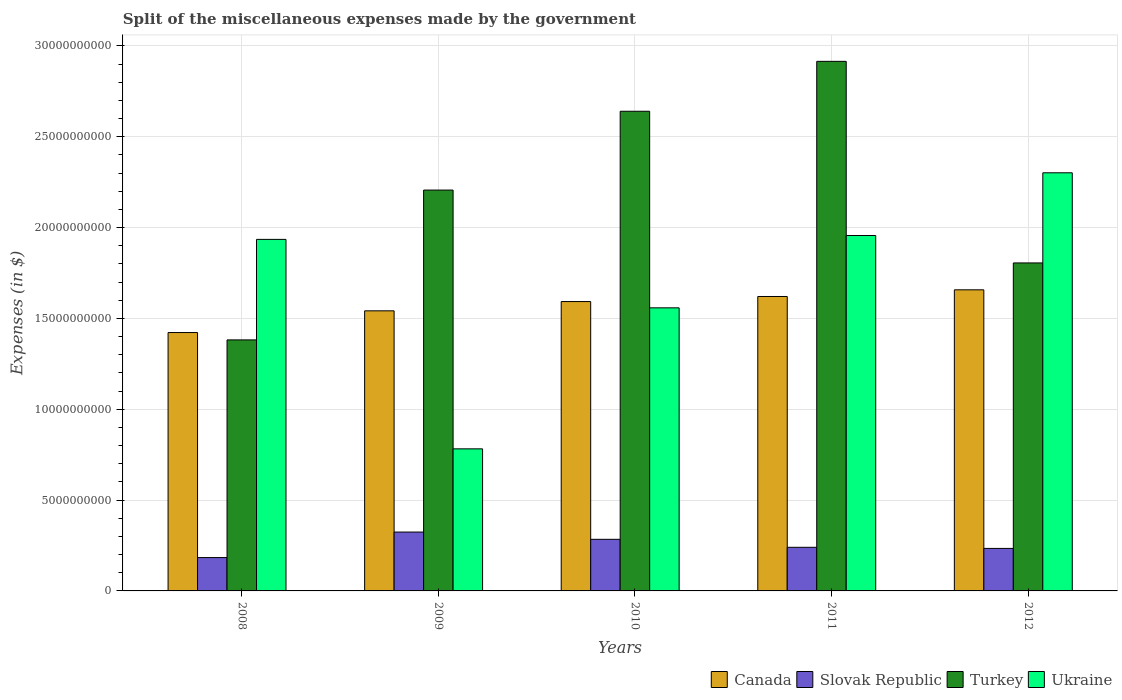How many different coloured bars are there?
Offer a terse response. 4. How many groups of bars are there?
Provide a succinct answer. 5. Are the number of bars per tick equal to the number of legend labels?
Offer a terse response. Yes. Are the number of bars on each tick of the X-axis equal?
Your response must be concise. Yes. How many bars are there on the 1st tick from the right?
Ensure brevity in your answer.  4. What is the label of the 4th group of bars from the left?
Provide a succinct answer. 2011. What is the miscellaneous expenses made by the government in Turkey in 2010?
Your answer should be compact. 2.64e+1. Across all years, what is the maximum miscellaneous expenses made by the government in Slovak Republic?
Your answer should be compact. 3.24e+09. Across all years, what is the minimum miscellaneous expenses made by the government in Slovak Republic?
Ensure brevity in your answer.  1.84e+09. In which year was the miscellaneous expenses made by the government in Canada minimum?
Your response must be concise. 2008. What is the total miscellaneous expenses made by the government in Turkey in the graph?
Offer a terse response. 1.09e+11. What is the difference between the miscellaneous expenses made by the government in Slovak Republic in 2010 and that in 2011?
Your response must be concise. 4.40e+08. What is the difference between the miscellaneous expenses made by the government in Turkey in 2010 and the miscellaneous expenses made by the government in Slovak Republic in 2012?
Offer a very short reply. 2.41e+1. What is the average miscellaneous expenses made by the government in Ukraine per year?
Offer a very short reply. 1.71e+1. In the year 2010, what is the difference between the miscellaneous expenses made by the government in Canada and miscellaneous expenses made by the government in Turkey?
Offer a very short reply. -1.05e+1. What is the ratio of the miscellaneous expenses made by the government in Turkey in 2008 to that in 2009?
Offer a very short reply. 0.63. Is the miscellaneous expenses made by the government in Turkey in 2008 less than that in 2010?
Keep it short and to the point. Yes. What is the difference between the highest and the second highest miscellaneous expenses made by the government in Turkey?
Give a very brief answer. 2.75e+09. What is the difference between the highest and the lowest miscellaneous expenses made by the government in Canada?
Offer a very short reply. 2.35e+09. Is the sum of the miscellaneous expenses made by the government in Ukraine in 2008 and 2010 greater than the maximum miscellaneous expenses made by the government in Turkey across all years?
Give a very brief answer. Yes. What does the 3rd bar from the right in 2010 represents?
Offer a terse response. Slovak Republic. Are the values on the major ticks of Y-axis written in scientific E-notation?
Provide a short and direct response. No. How many legend labels are there?
Provide a short and direct response. 4. How are the legend labels stacked?
Make the answer very short. Horizontal. What is the title of the graph?
Provide a short and direct response. Split of the miscellaneous expenses made by the government. What is the label or title of the X-axis?
Ensure brevity in your answer.  Years. What is the label or title of the Y-axis?
Your response must be concise. Expenses (in $). What is the Expenses (in $) in Canada in 2008?
Your response must be concise. 1.42e+1. What is the Expenses (in $) of Slovak Republic in 2008?
Offer a terse response. 1.84e+09. What is the Expenses (in $) of Turkey in 2008?
Your answer should be compact. 1.38e+1. What is the Expenses (in $) of Ukraine in 2008?
Your response must be concise. 1.93e+1. What is the Expenses (in $) in Canada in 2009?
Offer a very short reply. 1.54e+1. What is the Expenses (in $) in Slovak Republic in 2009?
Offer a terse response. 3.24e+09. What is the Expenses (in $) in Turkey in 2009?
Provide a succinct answer. 2.21e+1. What is the Expenses (in $) of Ukraine in 2009?
Offer a very short reply. 7.82e+09. What is the Expenses (in $) in Canada in 2010?
Provide a succinct answer. 1.59e+1. What is the Expenses (in $) of Slovak Republic in 2010?
Provide a short and direct response. 2.84e+09. What is the Expenses (in $) in Turkey in 2010?
Make the answer very short. 2.64e+1. What is the Expenses (in $) in Ukraine in 2010?
Keep it short and to the point. 1.56e+1. What is the Expenses (in $) of Canada in 2011?
Ensure brevity in your answer.  1.62e+1. What is the Expenses (in $) of Slovak Republic in 2011?
Your response must be concise. 2.40e+09. What is the Expenses (in $) of Turkey in 2011?
Provide a succinct answer. 2.91e+1. What is the Expenses (in $) of Ukraine in 2011?
Your answer should be very brief. 1.96e+1. What is the Expenses (in $) in Canada in 2012?
Provide a succinct answer. 1.66e+1. What is the Expenses (in $) in Slovak Republic in 2012?
Provide a succinct answer. 2.34e+09. What is the Expenses (in $) of Turkey in 2012?
Offer a terse response. 1.81e+1. What is the Expenses (in $) in Ukraine in 2012?
Your response must be concise. 2.30e+1. Across all years, what is the maximum Expenses (in $) in Canada?
Ensure brevity in your answer.  1.66e+1. Across all years, what is the maximum Expenses (in $) in Slovak Republic?
Provide a short and direct response. 3.24e+09. Across all years, what is the maximum Expenses (in $) of Turkey?
Your response must be concise. 2.91e+1. Across all years, what is the maximum Expenses (in $) in Ukraine?
Keep it short and to the point. 2.30e+1. Across all years, what is the minimum Expenses (in $) of Canada?
Give a very brief answer. 1.42e+1. Across all years, what is the minimum Expenses (in $) in Slovak Republic?
Your answer should be compact. 1.84e+09. Across all years, what is the minimum Expenses (in $) of Turkey?
Your answer should be very brief. 1.38e+1. Across all years, what is the minimum Expenses (in $) of Ukraine?
Offer a very short reply. 7.82e+09. What is the total Expenses (in $) of Canada in the graph?
Keep it short and to the point. 7.83e+1. What is the total Expenses (in $) of Slovak Republic in the graph?
Provide a succinct answer. 1.27e+1. What is the total Expenses (in $) of Turkey in the graph?
Make the answer very short. 1.09e+11. What is the total Expenses (in $) of Ukraine in the graph?
Provide a short and direct response. 8.53e+1. What is the difference between the Expenses (in $) in Canada in 2008 and that in 2009?
Your answer should be compact. -1.19e+09. What is the difference between the Expenses (in $) of Slovak Republic in 2008 and that in 2009?
Provide a short and direct response. -1.41e+09. What is the difference between the Expenses (in $) in Turkey in 2008 and that in 2009?
Your answer should be compact. -8.25e+09. What is the difference between the Expenses (in $) of Ukraine in 2008 and that in 2009?
Your answer should be compact. 1.15e+1. What is the difference between the Expenses (in $) of Canada in 2008 and that in 2010?
Offer a very short reply. -1.70e+09. What is the difference between the Expenses (in $) of Slovak Republic in 2008 and that in 2010?
Make the answer very short. -1.00e+09. What is the difference between the Expenses (in $) of Turkey in 2008 and that in 2010?
Offer a very short reply. -1.26e+1. What is the difference between the Expenses (in $) of Ukraine in 2008 and that in 2010?
Your answer should be compact. 3.77e+09. What is the difference between the Expenses (in $) of Canada in 2008 and that in 2011?
Ensure brevity in your answer.  -1.98e+09. What is the difference between the Expenses (in $) in Slovak Republic in 2008 and that in 2011?
Your answer should be very brief. -5.65e+08. What is the difference between the Expenses (in $) of Turkey in 2008 and that in 2011?
Give a very brief answer. -1.53e+1. What is the difference between the Expenses (in $) of Ukraine in 2008 and that in 2011?
Keep it short and to the point. -2.13e+08. What is the difference between the Expenses (in $) in Canada in 2008 and that in 2012?
Offer a terse response. -2.35e+09. What is the difference between the Expenses (in $) of Slovak Republic in 2008 and that in 2012?
Offer a very short reply. -5.04e+08. What is the difference between the Expenses (in $) in Turkey in 2008 and that in 2012?
Offer a very short reply. -4.24e+09. What is the difference between the Expenses (in $) of Ukraine in 2008 and that in 2012?
Make the answer very short. -3.66e+09. What is the difference between the Expenses (in $) of Canada in 2009 and that in 2010?
Your response must be concise. -5.11e+08. What is the difference between the Expenses (in $) in Slovak Republic in 2009 and that in 2010?
Keep it short and to the point. 4.00e+08. What is the difference between the Expenses (in $) in Turkey in 2009 and that in 2010?
Ensure brevity in your answer.  -4.34e+09. What is the difference between the Expenses (in $) of Ukraine in 2009 and that in 2010?
Give a very brief answer. -7.76e+09. What is the difference between the Expenses (in $) in Canada in 2009 and that in 2011?
Offer a very short reply. -7.90e+08. What is the difference between the Expenses (in $) of Slovak Republic in 2009 and that in 2011?
Keep it short and to the point. 8.40e+08. What is the difference between the Expenses (in $) of Turkey in 2009 and that in 2011?
Provide a succinct answer. -7.08e+09. What is the difference between the Expenses (in $) in Ukraine in 2009 and that in 2011?
Ensure brevity in your answer.  -1.17e+1. What is the difference between the Expenses (in $) in Canada in 2009 and that in 2012?
Give a very brief answer. -1.16e+09. What is the difference between the Expenses (in $) of Slovak Republic in 2009 and that in 2012?
Offer a terse response. 9.01e+08. What is the difference between the Expenses (in $) of Turkey in 2009 and that in 2012?
Ensure brevity in your answer.  4.01e+09. What is the difference between the Expenses (in $) in Ukraine in 2009 and that in 2012?
Offer a terse response. -1.52e+1. What is the difference between the Expenses (in $) in Canada in 2010 and that in 2011?
Your answer should be compact. -2.79e+08. What is the difference between the Expenses (in $) of Slovak Republic in 2010 and that in 2011?
Your answer should be compact. 4.40e+08. What is the difference between the Expenses (in $) in Turkey in 2010 and that in 2011?
Give a very brief answer. -2.75e+09. What is the difference between the Expenses (in $) in Ukraine in 2010 and that in 2011?
Ensure brevity in your answer.  -3.98e+09. What is the difference between the Expenses (in $) of Canada in 2010 and that in 2012?
Ensure brevity in your answer.  -6.46e+08. What is the difference between the Expenses (in $) of Slovak Republic in 2010 and that in 2012?
Ensure brevity in your answer.  5.01e+08. What is the difference between the Expenses (in $) of Turkey in 2010 and that in 2012?
Keep it short and to the point. 8.35e+09. What is the difference between the Expenses (in $) of Ukraine in 2010 and that in 2012?
Offer a terse response. -7.43e+09. What is the difference between the Expenses (in $) of Canada in 2011 and that in 2012?
Offer a very short reply. -3.67e+08. What is the difference between the Expenses (in $) in Slovak Republic in 2011 and that in 2012?
Offer a terse response. 6.13e+07. What is the difference between the Expenses (in $) in Turkey in 2011 and that in 2012?
Your answer should be very brief. 1.11e+1. What is the difference between the Expenses (in $) in Ukraine in 2011 and that in 2012?
Ensure brevity in your answer.  -3.45e+09. What is the difference between the Expenses (in $) in Canada in 2008 and the Expenses (in $) in Slovak Republic in 2009?
Provide a succinct answer. 1.10e+1. What is the difference between the Expenses (in $) of Canada in 2008 and the Expenses (in $) of Turkey in 2009?
Your response must be concise. -7.84e+09. What is the difference between the Expenses (in $) in Canada in 2008 and the Expenses (in $) in Ukraine in 2009?
Offer a very short reply. 6.40e+09. What is the difference between the Expenses (in $) in Slovak Republic in 2008 and the Expenses (in $) in Turkey in 2009?
Offer a terse response. -2.02e+1. What is the difference between the Expenses (in $) of Slovak Republic in 2008 and the Expenses (in $) of Ukraine in 2009?
Your answer should be very brief. -5.98e+09. What is the difference between the Expenses (in $) of Turkey in 2008 and the Expenses (in $) of Ukraine in 2009?
Your response must be concise. 6.00e+09. What is the difference between the Expenses (in $) of Canada in 2008 and the Expenses (in $) of Slovak Republic in 2010?
Offer a terse response. 1.14e+1. What is the difference between the Expenses (in $) in Canada in 2008 and the Expenses (in $) in Turkey in 2010?
Provide a succinct answer. -1.22e+1. What is the difference between the Expenses (in $) of Canada in 2008 and the Expenses (in $) of Ukraine in 2010?
Your answer should be very brief. -1.36e+09. What is the difference between the Expenses (in $) in Slovak Republic in 2008 and the Expenses (in $) in Turkey in 2010?
Your response must be concise. -2.46e+1. What is the difference between the Expenses (in $) in Slovak Republic in 2008 and the Expenses (in $) in Ukraine in 2010?
Offer a very short reply. -1.37e+1. What is the difference between the Expenses (in $) of Turkey in 2008 and the Expenses (in $) of Ukraine in 2010?
Offer a very short reply. -1.76e+09. What is the difference between the Expenses (in $) of Canada in 2008 and the Expenses (in $) of Slovak Republic in 2011?
Make the answer very short. 1.18e+1. What is the difference between the Expenses (in $) in Canada in 2008 and the Expenses (in $) in Turkey in 2011?
Make the answer very short. -1.49e+1. What is the difference between the Expenses (in $) of Canada in 2008 and the Expenses (in $) of Ukraine in 2011?
Ensure brevity in your answer.  -5.34e+09. What is the difference between the Expenses (in $) in Slovak Republic in 2008 and the Expenses (in $) in Turkey in 2011?
Your answer should be compact. -2.73e+1. What is the difference between the Expenses (in $) in Slovak Republic in 2008 and the Expenses (in $) in Ukraine in 2011?
Keep it short and to the point. -1.77e+1. What is the difference between the Expenses (in $) of Turkey in 2008 and the Expenses (in $) of Ukraine in 2011?
Offer a terse response. -5.75e+09. What is the difference between the Expenses (in $) of Canada in 2008 and the Expenses (in $) of Slovak Republic in 2012?
Keep it short and to the point. 1.19e+1. What is the difference between the Expenses (in $) of Canada in 2008 and the Expenses (in $) of Turkey in 2012?
Provide a short and direct response. -3.83e+09. What is the difference between the Expenses (in $) of Canada in 2008 and the Expenses (in $) of Ukraine in 2012?
Provide a succinct answer. -8.79e+09. What is the difference between the Expenses (in $) of Slovak Republic in 2008 and the Expenses (in $) of Turkey in 2012?
Your response must be concise. -1.62e+1. What is the difference between the Expenses (in $) of Slovak Republic in 2008 and the Expenses (in $) of Ukraine in 2012?
Your answer should be compact. -2.12e+1. What is the difference between the Expenses (in $) of Turkey in 2008 and the Expenses (in $) of Ukraine in 2012?
Keep it short and to the point. -9.20e+09. What is the difference between the Expenses (in $) in Canada in 2009 and the Expenses (in $) in Slovak Republic in 2010?
Your answer should be compact. 1.26e+1. What is the difference between the Expenses (in $) of Canada in 2009 and the Expenses (in $) of Turkey in 2010?
Make the answer very short. -1.10e+1. What is the difference between the Expenses (in $) of Canada in 2009 and the Expenses (in $) of Ukraine in 2010?
Give a very brief answer. -1.65e+08. What is the difference between the Expenses (in $) of Slovak Republic in 2009 and the Expenses (in $) of Turkey in 2010?
Keep it short and to the point. -2.32e+1. What is the difference between the Expenses (in $) of Slovak Republic in 2009 and the Expenses (in $) of Ukraine in 2010?
Give a very brief answer. -1.23e+1. What is the difference between the Expenses (in $) of Turkey in 2009 and the Expenses (in $) of Ukraine in 2010?
Your response must be concise. 6.48e+09. What is the difference between the Expenses (in $) of Canada in 2009 and the Expenses (in $) of Slovak Republic in 2011?
Keep it short and to the point. 1.30e+1. What is the difference between the Expenses (in $) of Canada in 2009 and the Expenses (in $) of Turkey in 2011?
Make the answer very short. -1.37e+1. What is the difference between the Expenses (in $) of Canada in 2009 and the Expenses (in $) of Ukraine in 2011?
Ensure brevity in your answer.  -4.15e+09. What is the difference between the Expenses (in $) of Slovak Republic in 2009 and the Expenses (in $) of Turkey in 2011?
Your response must be concise. -2.59e+1. What is the difference between the Expenses (in $) in Slovak Republic in 2009 and the Expenses (in $) in Ukraine in 2011?
Your response must be concise. -1.63e+1. What is the difference between the Expenses (in $) of Turkey in 2009 and the Expenses (in $) of Ukraine in 2011?
Your answer should be compact. 2.50e+09. What is the difference between the Expenses (in $) in Canada in 2009 and the Expenses (in $) in Slovak Republic in 2012?
Your answer should be compact. 1.31e+1. What is the difference between the Expenses (in $) of Canada in 2009 and the Expenses (in $) of Turkey in 2012?
Offer a terse response. -2.64e+09. What is the difference between the Expenses (in $) in Canada in 2009 and the Expenses (in $) in Ukraine in 2012?
Offer a very short reply. -7.60e+09. What is the difference between the Expenses (in $) in Slovak Republic in 2009 and the Expenses (in $) in Turkey in 2012?
Keep it short and to the point. -1.48e+1. What is the difference between the Expenses (in $) in Slovak Republic in 2009 and the Expenses (in $) in Ukraine in 2012?
Your answer should be very brief. -1.98e+1. What is the difference between the Expenses (in $) of Turkey in 2009 and the Expenses (in $) of Ukraine in 2012?
Give a very brief answer. -9.51e+08. What is the difference between the Expenses (in $) of Canada in 2010 and the Expenses (in $) of Slovak Republic in 2011?
Give a very brief answer. 1.35e+1. What is the difference between the Expenses (in $) of Canada in 2010 and the Expenses (in $) of Turkey in 2011?
Make the answer very short. -1.32e+1. What is the difference between the Expenses (in $) in Canada in 2010 and the Expenses (in $) in Ukraine in 2011?
Keep it short and to the point. -3.64e+09. What is the difference between the Expenses (in $) of Slovak Republic in 2010 and the Expenses (in $) of Turkey in 2011?
Give a very brief answer. -2.63e+1. What is the difference between the Expenses (in $) in Slovak Republic in 2010 and the Expenses (in $) in Ukraine in 2011?
Provide a short and direct response. -1.67e+1. What is the difference between the Expenses (in $) in Turkey in 2010 and the Expenses (in $) in Ukraine in 2011?
Your response must be concise. 6.84e+09. What is the difference between the Expenses (in $) of Canada in 2010 and the Expenses (in $) of Slovak Republic in 2012?
Keep it short and to the point. 1.36e+1. What is the difference between the Expenses (in $) of Canada in 2010 and the Expenses (in $) of Turkey in 2012?
Provide a succinct answer. -2.13e+09. What is the difference between the Expenses (in $) of Canada in 2010 and the Expenses (in $) of Ukraine in 2012?
Your answer should be compact. -7.09e+09. What is the difference between the Expenses (in $) in Slovak Republic in 2010 and the Expenses (in $) in Turkey in 2012?
Your answer should be very brief. -1.52e+1. What is the difference between the Expenses (in $) of Slovak Republic in 2010 and the Expenses (in $) of Ukraine in 2012?
Your answer should be very brief. -2.02e+1. What is the difference between the Expenses (in $) of Turkey in 2010 and the Expenses (in $) of Ukraine in 2012?
Make the answer very short. 3.39e+09. What is the difference between the Expenses (in $) in Canada in 2011 and the Expenses (in $) in Slovak Republic in 2012?
Offer a very short reply. 1.39e+1. What is the difference between the Expenses (in $) in Canada in 2011 and the Expenses (in $) in Turkey in 2012?
Ensure brevity in your answer.  -1.85e+09. What is the difference between the Expenses (in $) in Canada in 2011 and the Expenses (in $) in Ukraine in 2012?
Provide a short and direct response. -6.81e+09. What is the difference between the Expenses (in $) in Slovak Republic in 2011 and the Expenses (in $) in Turkey in 2012?
Make the answer very short. -1.57e+1. What is the difference between the Expenses (in $) of Slovak Republic in 2011 and the Expenses (in $) of Ukraine in 2012?
Ensure brevity in your answer.  -2.06e+1. What is the difference between the Expenses (in $) of Turkey in 2011 and the Expenses (in $) of Ukraine in 2012?
Keep it short and to the point. 6.13e+09. What is the average Expenses (in $) in Canada per year?
Offer a terse response. 1.57e+1. What is the average Expenses (in $) in Slovak Republic per year?
Give a very brief answer. 2.53e+09. What is the average Expenses (in $) of Turkey per year?
Your answer should be very brief. 2.19e+1. What is the average Expenses (in $) of Ukraine per year?
Provide a short and direct response. 1.71e+1. In the year 2008, what is the difference between the Expenses (in $) of Canada and Expenses (in $) of Slovak Republic?
Your response must be concise. 1.24e+1. In the year 2008, what is the difference between the Expenses (in $) in Canada and Expenses (in $) in Turkey?
Give a very brief answer. 4.05e+08. In the year 2008, what is the difference between the Expenses (in $) in Canada and Expenses (in $) in Ukraine?
Your answer should be compact. -5.13e+09. In the year 2008, what is the difference between the Expenses (in $) of Slovak Republic and Expenses (in $) of Turkey?
Your response must be concise. -1.20e+1. In the year 2008, what is the difference between the Expenses (in $) of Slovak Republic and Expenses (in $) of Ukraine?
Give a very brief answer. -1.75e+1. In the year 2008, what is the difference between the Expenses (in $) in Turkey and Expenses (in $) in Ukraine?
Ensure brevity in your answer.  -5.53e+09. In the year 2009, what is the difference between the Expenses (in $) in Canada and Expenses (in $) in Slovak Republic?
Your answer should be compact. 1.22e+1. In the year 2009, what is the difference between the Expenses (in $) in Canada and Expenses (in $) in Turkey?
Your answer should be compact. -6.65e+09. In the year 2009, what is the difference between the Expenses (in $) in Canada and Expenses (in $) in Ukraine?
Make the answer very short. 7.60e+09. In the year 2009, what is the difference between the Expenses (in $) in Slovak Republic and Expenses (in $) in Turkey?
Keep it short and to the point. -1.88e+1. In the year 2009, what is the difference between the Expenses (in $) of Slovak Republic and Expenses (in $) of Ukraine?
Offer a terse response. -4.58e+09. In the year 2009, what is the difference between the Expenses (in $) of Turkey and Expenses (in $) of Ukraine?
Give a very brief answer. 1.42e+1. In the year 2010, what is the difference between the Expenses (in $) of Canada and Expenses (in $) of Slovak Republic?
Your response must be concise. 1.31e+1. In the year 2010, what is the difference between the Expenses (in $) of Canada and Expenses (in $) of Turkey?
Your response must be concise. -1.05e+1. In the year 2010, what is the difference between the Expenses (in $) of Canada and Expenses (in $) of Ukraine?
Provide a short and direct response. 3.46e+08. In the year 2010, what is the difference between the Expenses (in $) in Slovak Republic and Expenses (in $) in Turkey?
Offer a very short reply. -2.36e+1. In the year 2010, what is the difference between the Expenses (in $) in Slovak Republic and Expenses (in $) in Ukraine?
Make the answer very short. -1.27e+1. In the year 2010, what is the difference between the Expenses (in $) of Turkey and Expenses (in $) of Ukraine?
Make the answer very short. 1.08e+1. In the year 2011, what is the difference between the Expenses (in $) in Canada and Expenses (in $) in Slovak Republic?
Offer a very short reply. 1.38e+1. In the year 2011, what is the difference between the Expenses (in $) of Canada and Expenses (in $) of Turkey?
Offer a very short reply. -1.29e+1. In the year 2011, what is the difference between the Expenses (in $) in Canada and Expenses (in $) in Ukraine?
Provide a succinct answer. -3.36e+09. In the year 2011, what is the difference between the Expenses (in $) of Slovak Republic and Expenses (in $) of Turkey?
Provide a short and direct response. -2.67e+1. In the year 2011, what is the difference between the Expenses (in $) of Slovak Republic and Expenses (in $) of Ukraine?
Your response must be concise. -1.72e+1. In the year 2011, what is the difference between the Expenses (in $) in Turkey and Expenses (in $) in Ukraine?
Provide a short and direct response. 9.59e+09. In the year 2012, what is the difference between the Expenses (in $) in Canada and Expenses (in $) in Slovak Republic?
Make the answer very short. 1.42e+1. In the year 2012, what is the difference between the Expenses (in $) of Canada and Expenses (in $) of Turkey?
Offer a terse response. -1.48e+09. In the year 2012, what is the difference between the Expenses (in $) in Canada and Expenses (in $) in Ukraine?
Your response must be concise. -6.44e+09. In the year 2012, what is the difference between the Expenses (in $) of Slovak Republic and Expenses (in $) of Turkey?
Give a very brief answer. -1.57e+1. In the year 2012, what is the difference between the Expenses (in $) of Slovak Republic and Expenses (in $) of Ukraine?
Offer a very short reply. -2.07e+1. In the year 2012, what is the difference between the Expenses (in $) in Turkey and Expenses (in $) in Ukraine?
Your answer should be very brief. -4.96e+09. What is the ratio of the Expenses (in $) in Canada in 2008 to that in 2009?
Offer a terse response. 0.92. What is the ratio of the Expenses (in $) in Slovak Republic in 2008 to that in 2009?
Keep it short and to the point. 0.57. What is the ratio of the Expenses (in $) of Turkey in 2008 to that in 2009?
Ensure brevity in your answer.  0.63. What is the ratio of the Expenses (in $) in Ukraine in 2008 to that in 2009?
Ensure brevity in your answer.  2.47. What is the ratio of the Expenses (in $) of Canada in 2008 to that in 2010?
Provide a short and direct response. 0.89. What is the ratio of the Expenses (in $) of Slovak Republic in 2008 to that in 2010?
Your answer should be compact. 0.65. What is the ratio of the Expenses (in $) of Turkey in 2008 to that in 2010?
Ensure brevity in your answer.  0.52. What is the ratio of the Expenses (in $) in Ukraine in 2008 to that in 2010?
Offer a very short reply. 1.24. What is the ratio of the Expenses (in $) of Canada in 2008 to that in 2011?
Your response must be concise. 0.88. What is the ratio of the Expenses (in $) in Slovak Republic in 2008 to that in 2011?
Your answer should be compact. 0.76. What is the ratio of the Expenses (in $) of Turkey in 2008 to that in 2011?
Provide a short and direct response. 0.47. What is the ratio of the Expenses (in $) in Ukraine in 2008 to that in 2011?
Keep it short and to the point. 0.99. What is the ratio of the Expenses (in $) in Canada in 2008 to that in 2012?
Give a very brief answer. 0.86. What is the ratio of the Expenses (in $) of Slovak Republic in 2008 to that in 2012?
Ensure brevity in your answer.  0.78. What is the ratio of the Expenses (in $) in Turkey in 2008 to that in 2012?
Keep it short and to the point. 0.77. What is the ratio of the Expenses (in $) in Ukraine in 2008 to that in 2012?
Provide a short and direct response. 0.84. What is the ratio of the Expenses (in $) of Canada in 2009 to that in 2010?
Keep it short and to the point. 0.97. What is the ratio of the Expenses (in $) of Slovak Republic in 2009 to that in 2010?
Keep it short and to the point. 1.14. What is the ratio of the Expenses (in $) of Turkey in 2009 to that in 2010?
Ensure brevity in your answer.  0.84. What is the ratio of the Expenses (in $) in Ukraine in 2009 to that in 2010?
Your answer should be very brief. 0.5. What is the ratio of the Expenses (in $) of Canada in 2009 to that in 2011?
Give a very brief answer. 0.95. What is the ratio of the Expenses (in $) of Slovak Republic in 2009 to that in 2011?
Make the answer very short. 1.35. What is the ratio of the Expenses (in $) of Turkey in 2009 to that in 2011?
Provide a succinct answer. 0.76. What is the ratio of the Expenses (in $) in Ukraine in 2009 to that in 2011?
Give a very brief answer. 0.4. What is the ratio of the Expenses (in $) of Canada in 2009 to that in 2012?
Your response must be concise. 0.93. What is the ratio of the Expenses (in $) in Slovak Republic in 2009 to that in 2012?
Make the answer very short. 1.39. What is the ratio of the Expenses (in $) of Turkey in 2009 to that in 2012?
Your response must be concise. 1.22. What is the ratio of the Expenses (in $) of Ukraine in 2009 to that in 2012?
Keep it short and to the point. 0.34. What is the ratio of the Expenses (in $) of Canada in 2010 to that in 2011?
Give a very brief answer. 0.98. What is the ratio of the Expenses (in $) of Slovak Republic in 2010 to that in 2011?
Provide a short and direct response. 1.18. What is the ratio of the Expenses (in $) of Turkey in 2010 to that in 2011?
Ensure brevity in your answer.  0.91. What is the ratio of the Expenses (in $) of Ukraine in 2010 to that in 2011?
Your answer should be compact. 0.8. What is the ratio of the Expenses (in $) in Slovak Republic in 2010 to that in 2012?
Offer a terse response. 1.21. What is the ratio of the Expenses (in $) in Turkey in 2010 to that in 2012?
Ensure brevity in your answer.  1.46. What is the ratio of the Expenses (in $) in Ukraine in 2010 to that in 2012?
Make the answer very short. 0.68. What is the ratio of the Expenses (in $) of Canada in 2011 to that in 2012?
Provide a succinct answer. 0.98. What is the ratio of the Expenses (in $) in Slovak Republic in 2011 to that in 2012?
Give a very brief answer. 1.03. What is the ratio of the Expenses (in $) in Turkey in 2011 to that in 2012?
Your response must be concise. 1.61. What is the ratio of the Expenses (in $) of Ukraine in 2011 to that in 2012?
Provide a succinct answer. 0.85. What is the difference between the highest and the second highest Expenses (in $) of Canada?
Offer a terse response. 3.67e+08. What is the difference between the highest and the second highest Expenses (in $) of Slovak Republic?
Your answer should be compact. 4.00e+08. What is the difference between the highest and the second highest Expenses (in $) of Turkey?
Provide a short and direct response. 2.75e+09. What is the difference between the highest and the second highest Expenses (in $) of Ukraine?
Ensure brevity in your answer.  3.45e+09. What is the difference between the highest and the lowest Expenses (in $) in Canada?
Ensure brevity in your answer.  2.35e+09. What is the difference between the highest and the lowest Expenses (in $) of Slovak Republic?
Your answer should be very brief. 1.41e+09. What is the difference between the highest and the lowest Expenses (in $) in Turkey?
Your answer should be very brief. 1.53e+1. What is the difference between the highest and the lowest Expenses (in $) in Ukraine?
Provide a short and direct response. 1.52e+1. 